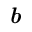Convert formula to latex. <formula><loc_0><loc_0><loc_500><loc_500>b</formula> 